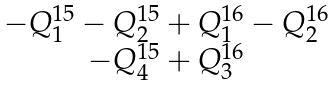Convert formula to latex. <formula><loc_0><loc_0><loc_500><loc_500>\begin{matrix} - Q ^ { 1 5 } _ { 1 } - Q ^ { 1 5 } _ { 2 } + Q ^ { 1 6 } _ { 1 } - Q ^ { 1 6 } _ { 2 } \\ - Q ^ { 1 5 } _ { 4 } + Q ^ { 1 6 } _ { 3 } \end{matrix}</formula> 